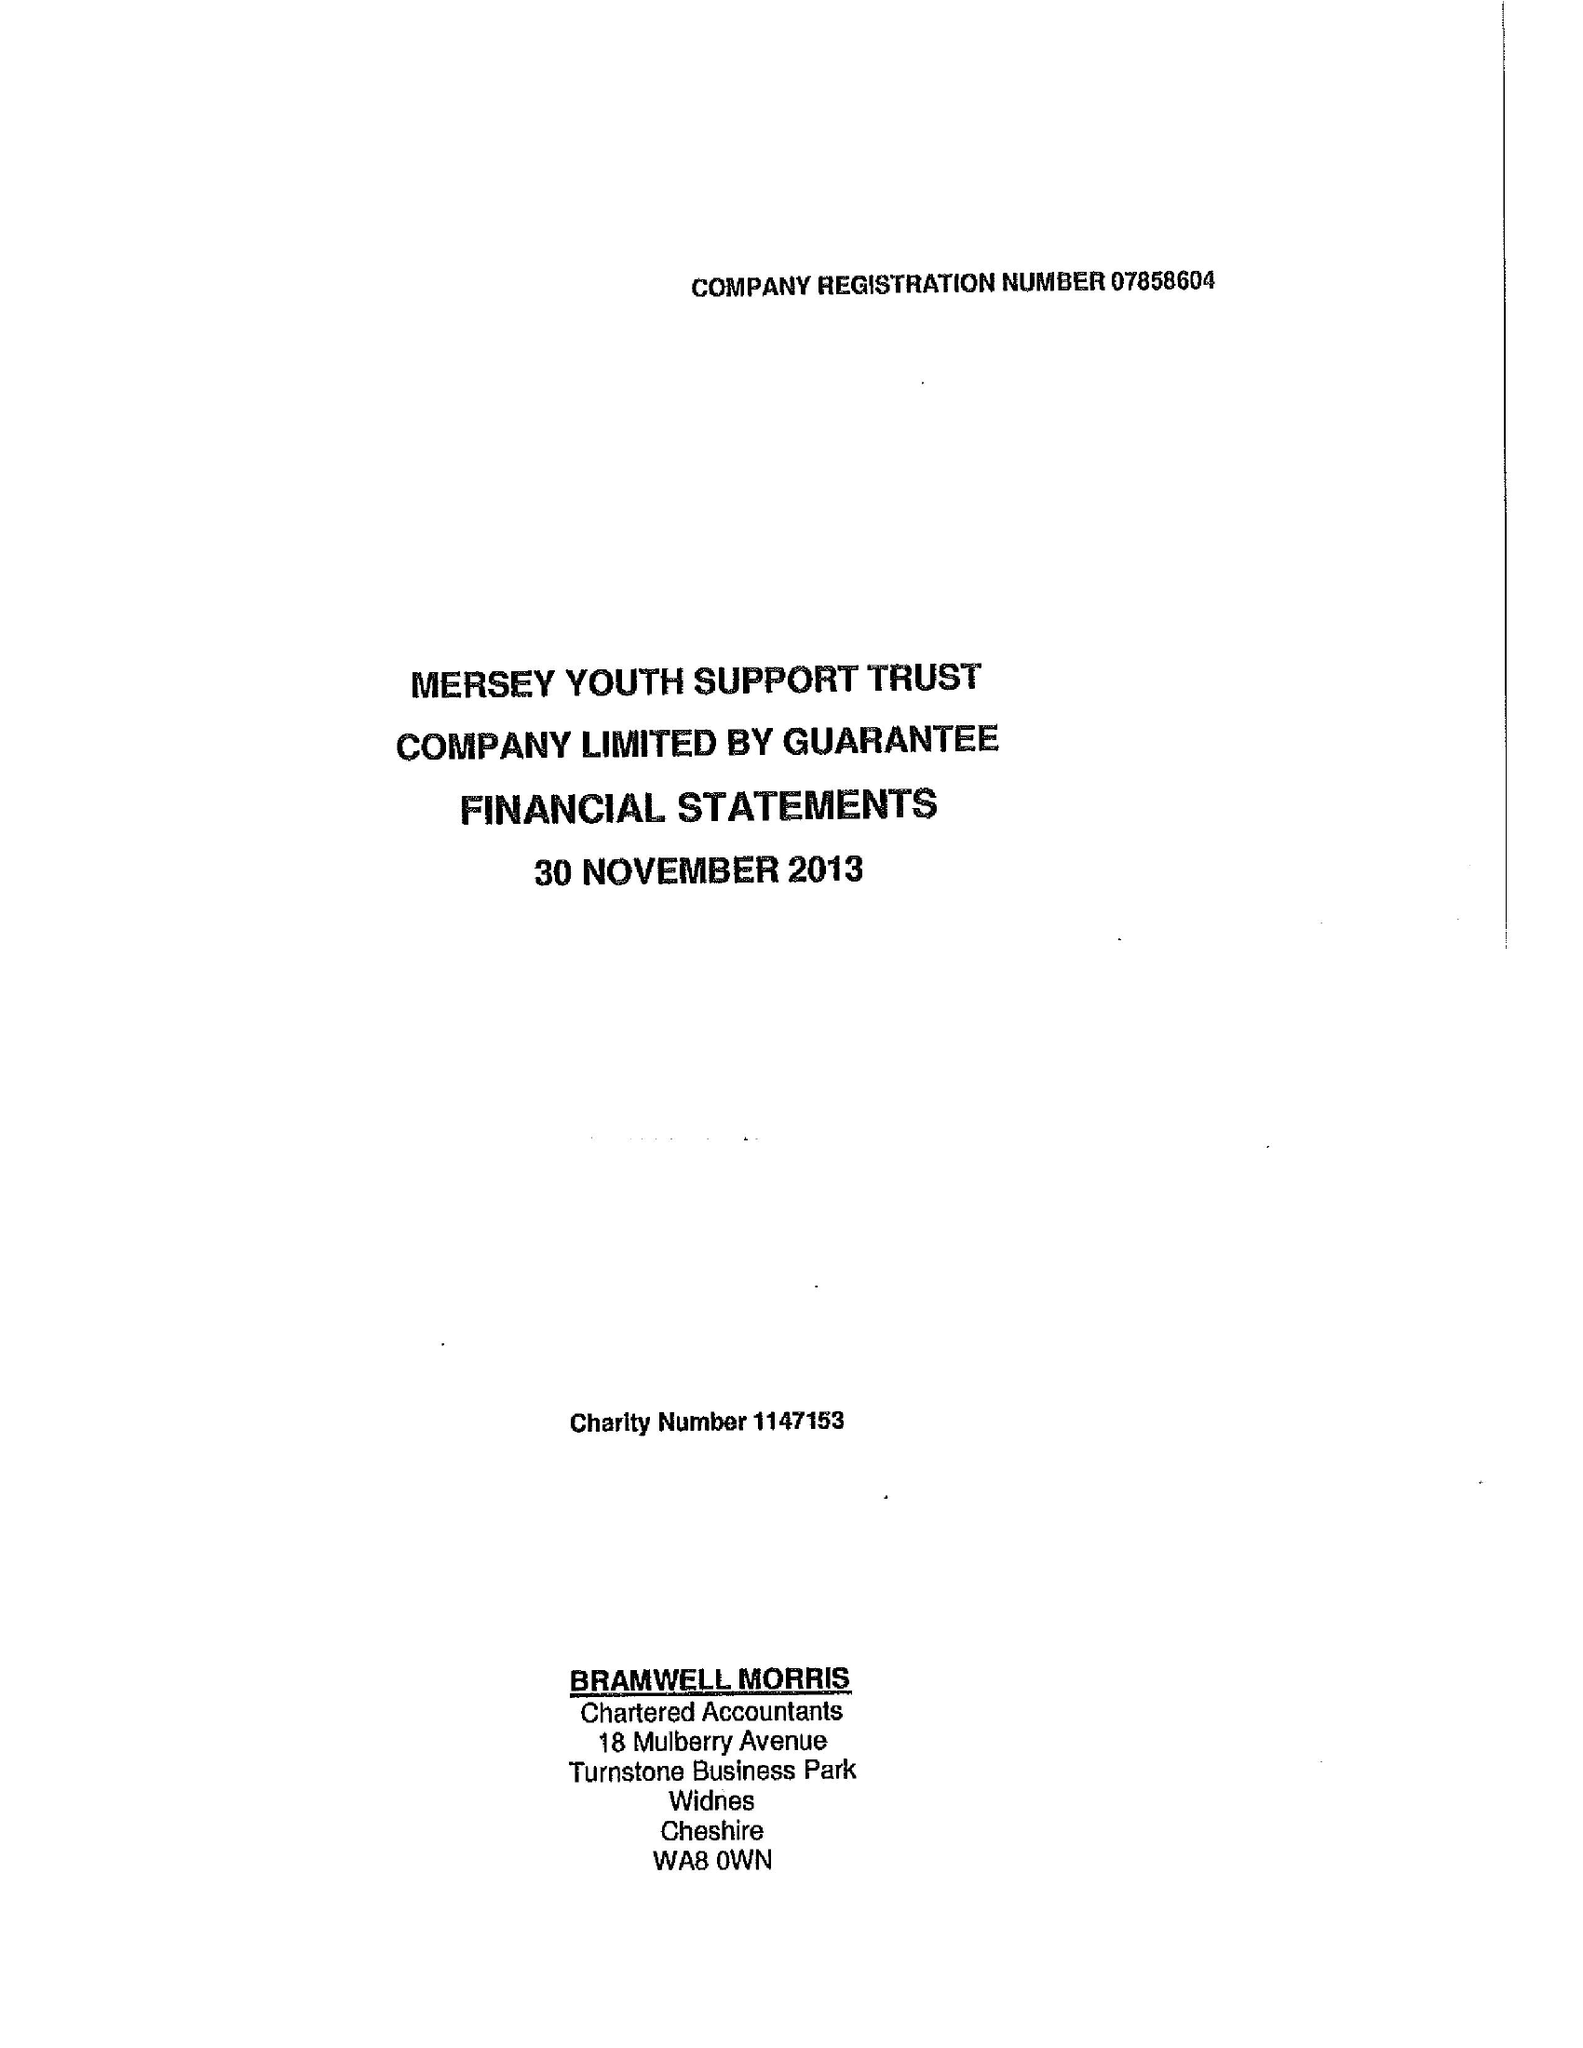What is the value for the spending_annually_in_british_pounds?
Answer the question using a single word or phrase. 83636.00 